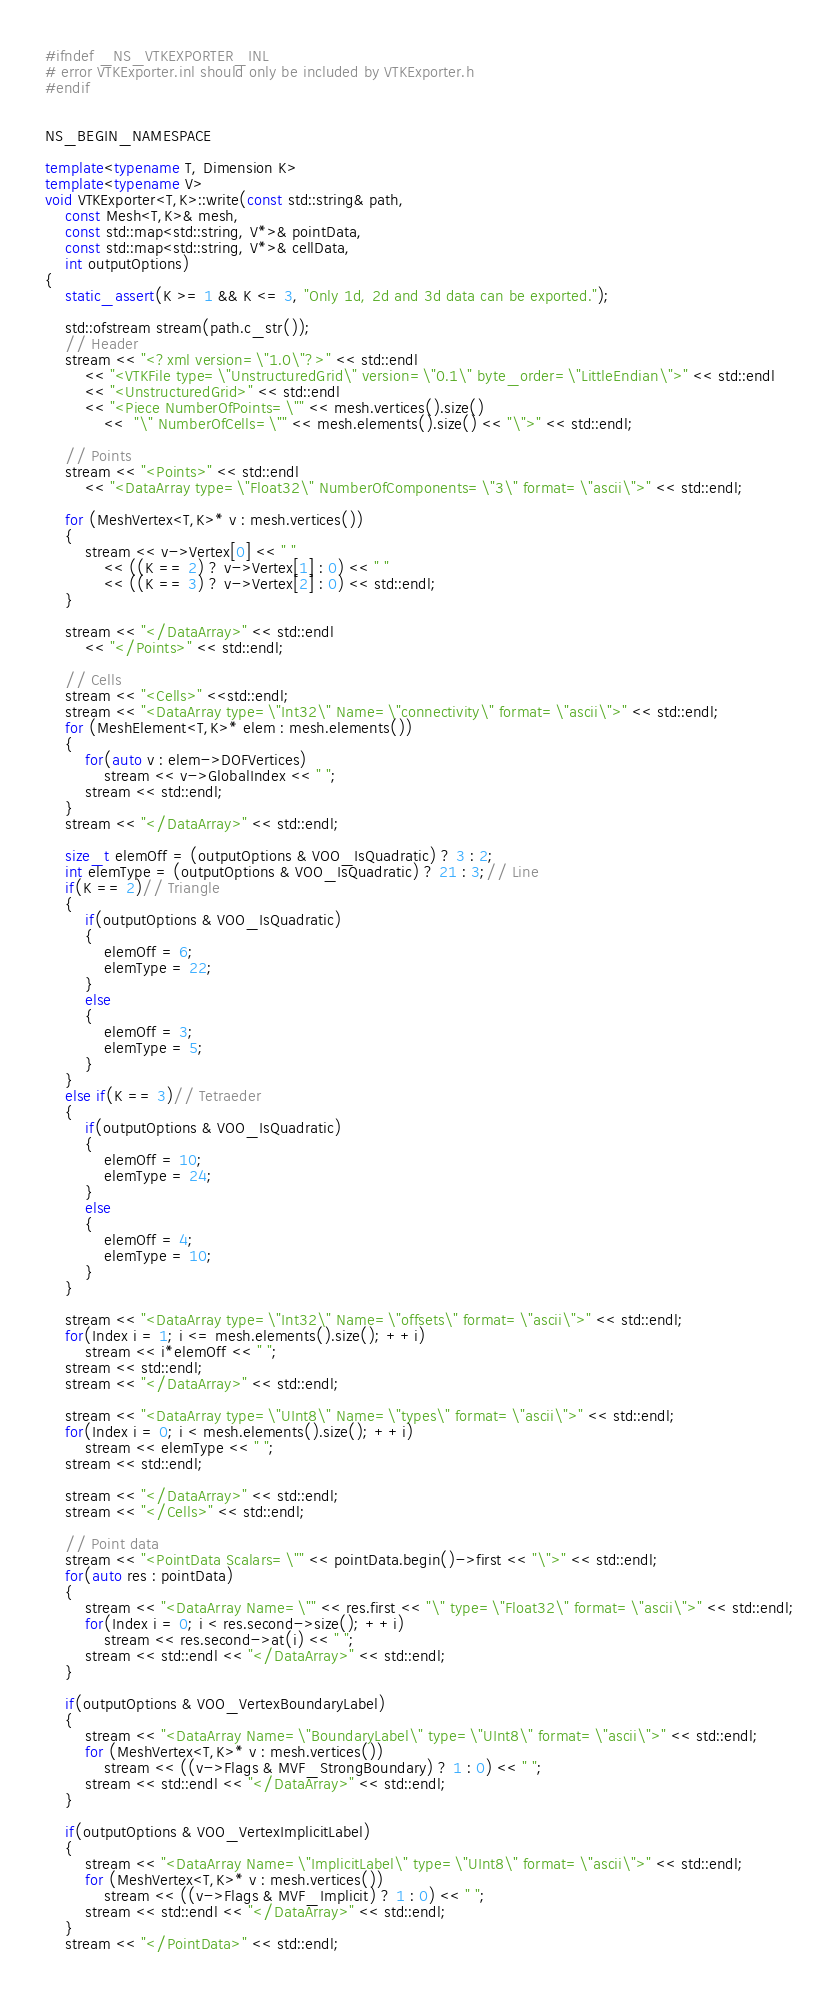<code> <loc_0><loc_0><loc_500><loc_500><_C++_>#ifndef _NS_VTKEXPORTER_INL
# error VTKExporter.inl should only be included by VTKExporter.h
#endif


NS_BEGIN_NAMESPACE

template<typename T, Dimension K>
template<typename V>
void VTKExporter<T,K>::write(const std::string& path,
	const Mesh<T,K>& mesh,
	const std::map<std::string, V*>& pointData,
	const std::map<std::string, V*>& cellData,
	int outputOptions)
{
	static_assert(K >= 1 && K <= 3, "Only 1d, 2d and 3d data can be exported.");

	std::ofstream stream(path.c_str());
	// Header
	stream << "<?xml version=\"1.0\"?>" << std::endl
		<< "<VTKFile type=\"UnstructuredGrid\" version=\"0.1\" byte_order=\"LittleEndian\">" << std::endl
		<< "<UnstructuredGrid>" << std::endl
		<< "<Piece NumberOfPoints=\"" << mesh.vertices().size() 
			<<  "\" NumberOfCells=\"" << mesh.elements().size() << "\">" << std::endl;

	// Points
	stream << "<Points>" << std::endl
		<< "<DataArray type=\"Float32\" NumberOfComponents=\"3\" format=\"ascii\">" << std::endl;
	
	for (MeshVertex<T,K>* v : mesh.vertices())
	{
		stream << v->Vertex[0] << " "
			<< ((K == 2) ? v->Vertex[1] : 0) << " "
			<< ((K == 3) ? v->Vertex[2] : 0) << std::endl;
	}

	stream << "</DataArray>" << std::endl
		<< "</Points>" << std::endl;

	// Cells
	stream << "<Cells>" <<std::endl;
	stream << "<DataArray type=\"Int32\" Name=\"connectivity\" format=\"ascii\">" << std::endl;
	for (MeshElement<T,K>* elem : mesh.elements())
	{
		for(auto v : elem->DOFVertices)
			stream << v->GlobalIndex << " ";
		stream << std::endl;
	}
	stream << "</DataArray>" << std::endl;

	size_t elemOff = (outputOptions & VOO_IsQuadratic) ? 3 : 2;
	int elemType = (outputOptions & VOO_IsQuadratic) ? 21 : 3;// Line
	if(K == 2)// Triangle
	{
		if(outputOptions & VOO_IsQuadratic)
		{
			elemOff = 6;
			elemType = 22;
		}
		else
		{
			elemOff = 3;
			elemType = 5;
		}
	}
	else if(K == 3)// Tetraeder
	{
		if(outputOptions & VOO_IsQuadratic)
		{
			elemOff = 10;
			elemType = 24;
		}
		else
		{
			elemOff = 4;
			elemType = 10;
		}
	}

	stream << "<DataArray type=\"Int32\" Name=\"offsets\" format=\"ascii\">" << std::endl;
	for(Index i = 1; i <= mesh.elements().size(); ++i)
		stream << i*elemOff << " ";
	stream << std::endl;
	stream << "</DataArray>" << std::endl;

	stream << "<DataArray type=\"UInt8\" Name=\"types\" format=\"ascii\">" << std::endl;
	for(Index i = 0; i < mesh.elements().size(); ++i)
		stream << elemType << " ";
	stream << std::endl;
	
	stream << "</DataArray>" << std::endl;
	stream << "</Cells>" << std::endl;

	// Point data
	stream << "<PointData Scalars=\"" << pointData.begin()->first << "\">" << std::endl;
	for(auto res : pointData)
	{
		stream << "<DataArray Name=\"" << res.first << "\" type=\"Float32\" format=\"ascii\">" << std::endl;
		for(Index i = 0; i < res.second->size(); ++i)
			stream << res.second->at(i) << " ";
		stream << std::endl << "</DataArray>" << std::endl;
	}

	if(outputOptions & VOO_VertexBoundaryLabel)
	{
		stream << "<DataArray Name=\"BoundaryLabel\" type=\"UInt8\" format=\"ascii\">" << std::endl;
		for (MeshVertex<T,K>* v : mesh.vertices())
			stream << ((v->Flags & MVF_StrongBoundary) ? 1 : 0) << " ";
		stream << std::endl << "</DataArray>" << std::endl;
	}

	if(outputOptions & VOO_VertexImplicitLabel)
	{
		stream << "<DataArray Name=\"ImplicitLabel\" type=\"UInt8\" format=\"ascii\">" << std::endl;
		for (MeshVertex<T,K>* v : mesh.vertices())
			stream << ((v->Flags & MVF_Implicit) ? 1 : 0) << " ";
		stream << std::endl << "</DataArray>" << std::endl;
	}
	stream << "</PointData>" << std::endl;
</code> 